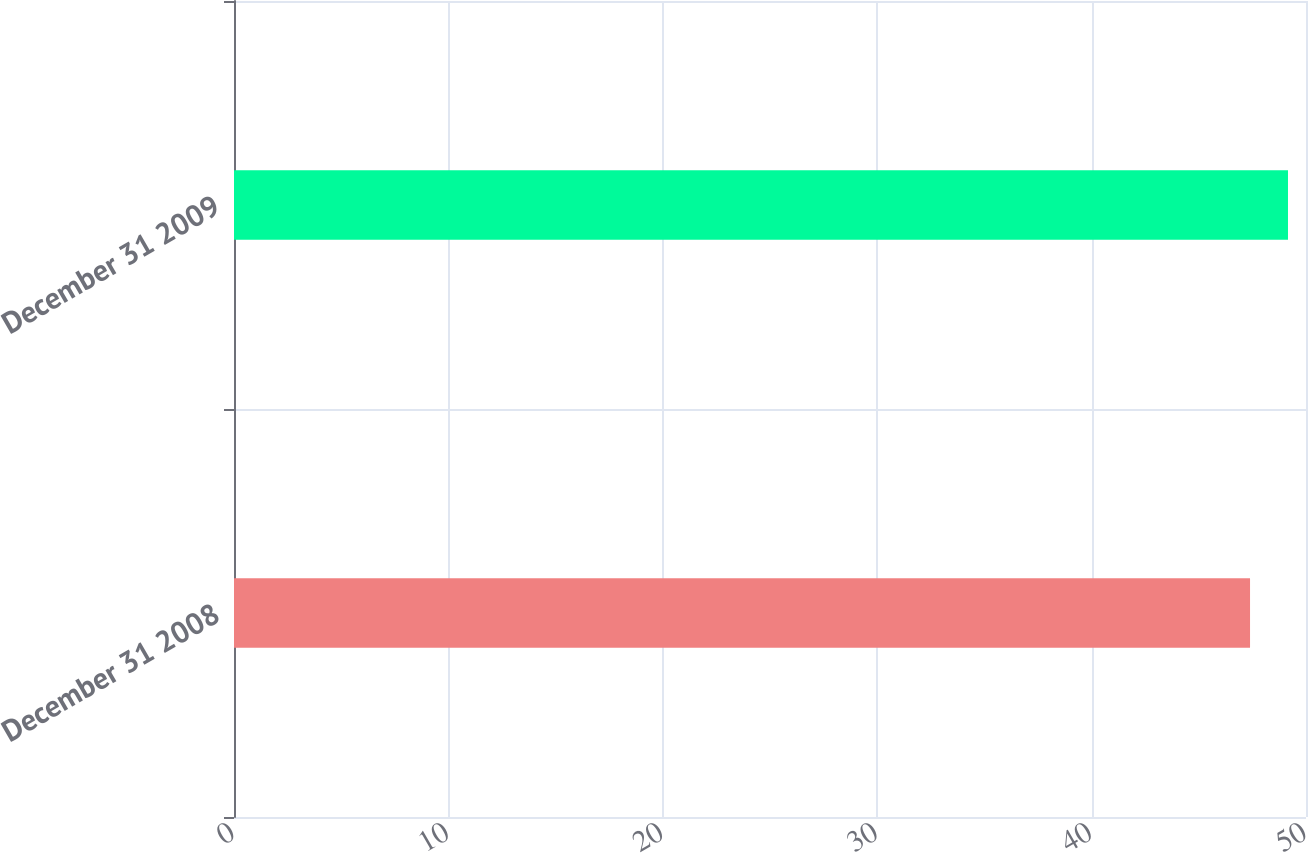<chart> <loc_0><loc_0><loc_500><loc_500><bar_chart><fcel>December 31 2008<fcel>December 31 2009<nl><fcel>47.39<fcel>49.16<nl></chart> 